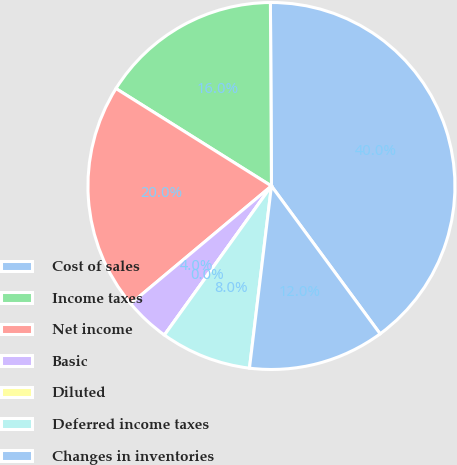Convert chart. <chart><loc_0><loc_0><loc_500><loc_500><pie_chart><fcel>Cost of sales<fcel>Income taxes<fcel>Net income<fcel>Basic<fcel>Diluted<fcel>Deferred income taxes<fcel>Changes in inventories<nl><fcel>40.0%<fcel>16.0%<fcel>20.0%<fcel>4.0%<fcel>0.0%<fcel>8.0%<fcel>12.0%<nl></chart> 